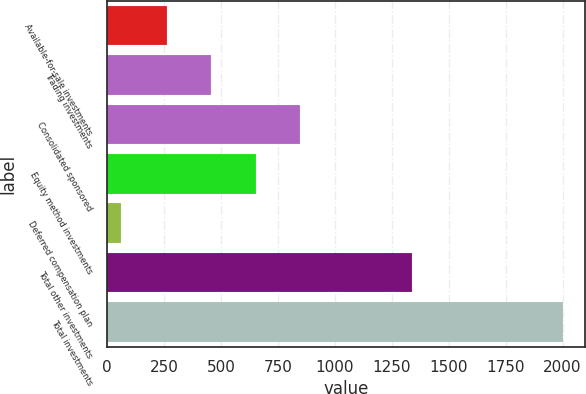Convert chart. <chart><loc_0><loc_0><loc_500><loc_500><bar_chart><fcel>Available-for-sale investments<fcel>Trading investments<fcel>Consolidated sponsored<fcel>Equity method investments<fcel>Deferred compensation plan<fcel>Total other investments<fcel>Total investments<nl><fcel>264<fcel>458<fcel>846<fcel>652<fcel>60<fcel>1341<fcel>2000<nl></chart> 